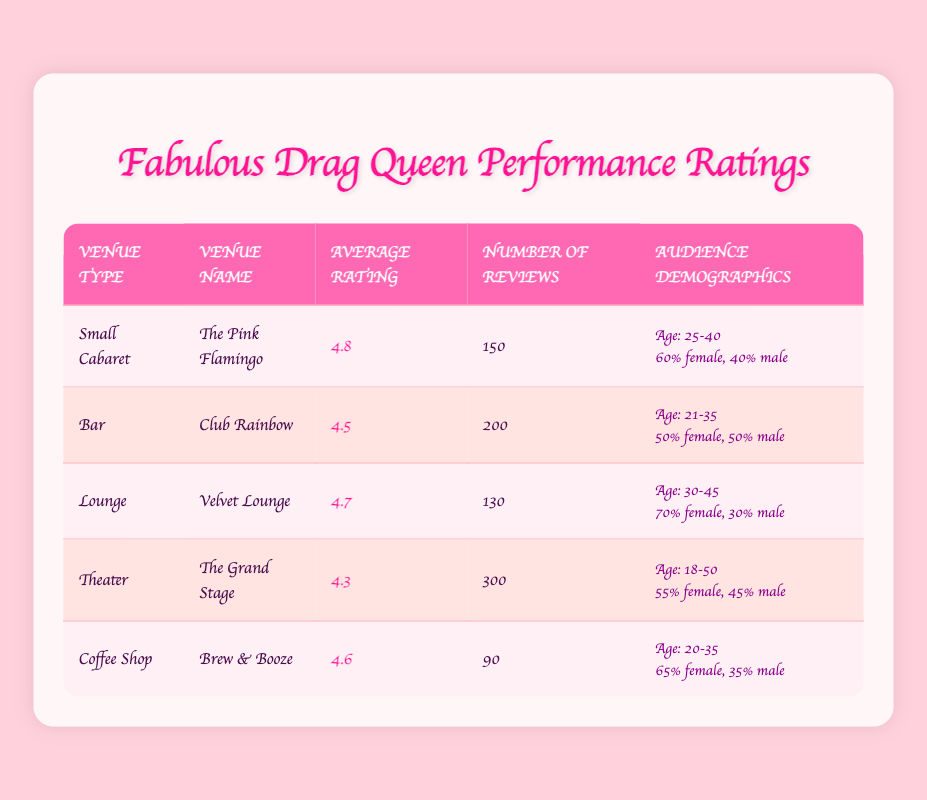What is the average rating of The Pink Flamingo? The average rating for The Pink Flamingo is provided in the third column of the table and it is 4.8.
Answer: 4.8 Which venue type has the highest average rating? The highest average rating is found in the "Small Cabaret" venue type, specifically at The Pink Flamingo, which has an average rating of 4.8.
Answer: Small Cabaret What is the total number of reviews for all venues? To find the total number of reviews, we sum the number of reviews from each venue: 150 (The Pink Flamingo) + 200 (Club Rainbow) + 130 (Velvet Lounge) + 300 (The Grand Stage) + 90 (Brew & Booze) = 1,070.
Answer: 1070 Is Club Rainbow rated higher than Velvet Lounge? By comparing the average ratings in the table, Club Rainbow has an average rating of 4.5 while Velvet Lounge has 4.7. Therefore, Club Rainbow is not rated higher than Velvet Lounge.
Answer: No What percentage of the audience at Brew & Booze is female? The audience demographic states that the gender ratio at Brew & Booze is 65% female. This data is taken directly from the audience demographics column.
Answer: 65% Which venue has the fewest number of reviews, and how many are there? Looking at the number of reviews for each venue, Brew & Booze has the fewest reviews at 90. This detail is found in the fourth column of the table.
Answer: Brew & Booze, 90 What is the average rating for venues that are classified as "Lounge" and "Bar"? The average rating for Lounge (Velvet Lounge) is 4.7 and for Bar (Club Rainbow) is 4.5. To find the overall average, we add these ratings (4.7 + 4.5) and divide by 2, giving (9.2 / 2) = 4.6.
Answer: 4.6 Are there more females or males in the audience at The Grand Stage? The audience demographics state that the gender ratio at The Grand Stage is 55% female and 45% male. Since 55% is greater than 45%, there are more females than males.
Answer: Yes What is the overall average rating for all venues? To calculate the overall average rating, sum all average ratings: 4.8 (The Pink Flamingo) + 4.5 (Club Rainbow) + 4.7 (Velvet Lounge) + 4.3 (The Grand Stage) + 4.6 (Brew & Booze) = 24. Since there are 5 venues, divide 24 by 5 to get an average rating of 4.8.
Answer: 4.8 